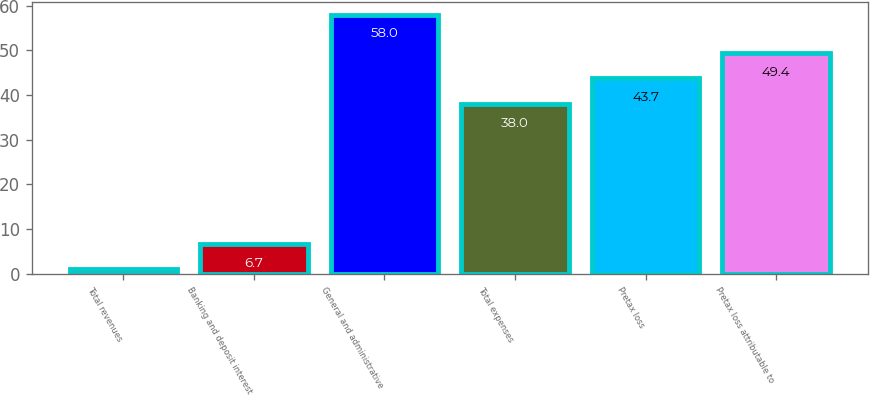Convert chart to OTSL. <chart><loc_0><loc_0><loc_500><loc_500><bar_chart><fcel>Total revenues<fcel>Banking and deposit interest<fcel>General and administrative<fcel>Total expenses<fcel>Pretax loss<fcel>Pretax loss attributable to<nl><fcel>1<fcel>6.7<fcel>58<fcel>38<fcel>43.7<fcel>49.4<nl></chart> 